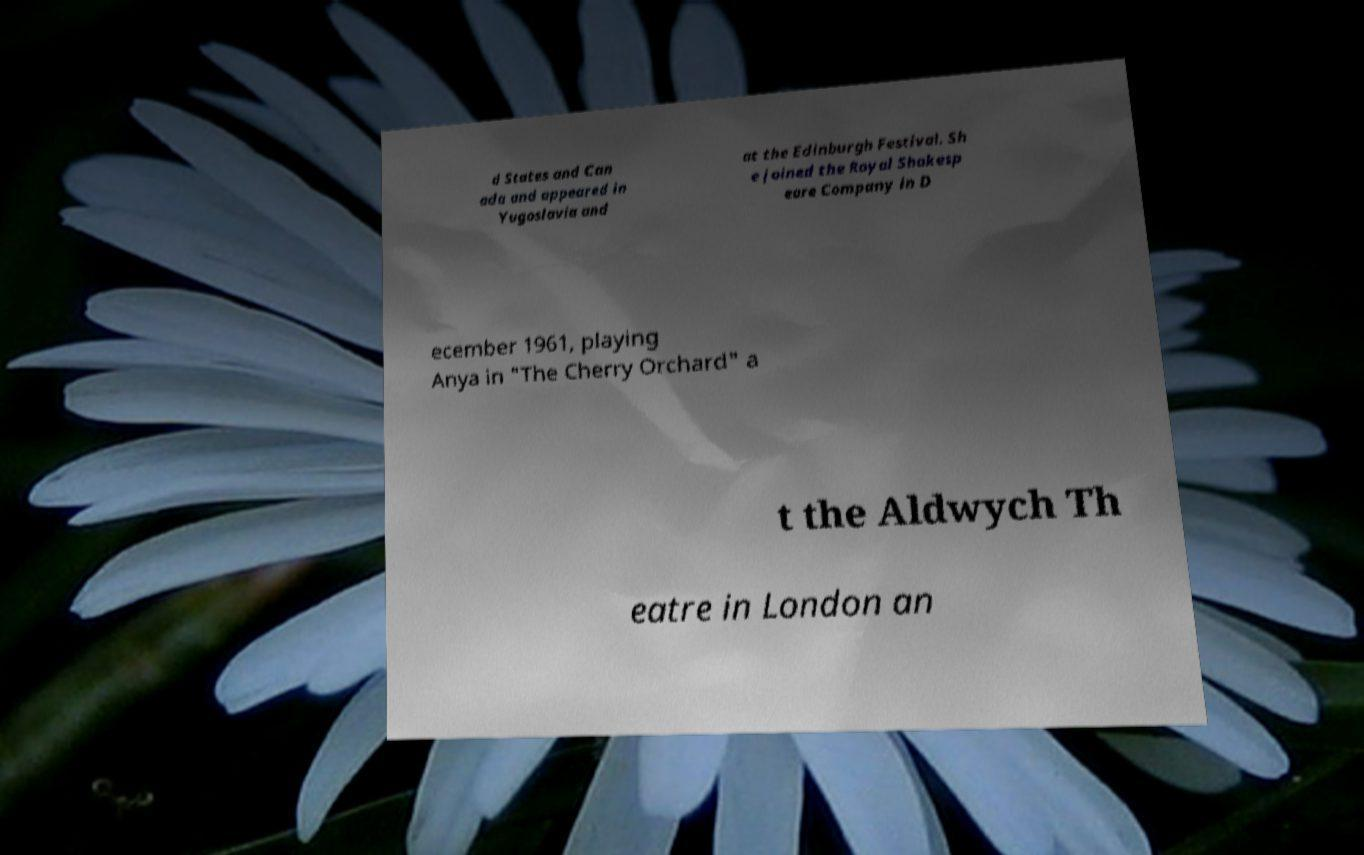What messages or text are displayed in this image? I need them in a readable, typed format. d States and Can ada and appeared in Yugoslavia and at the Edinburgh Festival. Sh e joined the Royal Shakesp eare Company in D ecember 1961, playing Anya in "The Cherry Orchard" a t the Aldwych Th eatre in London an 